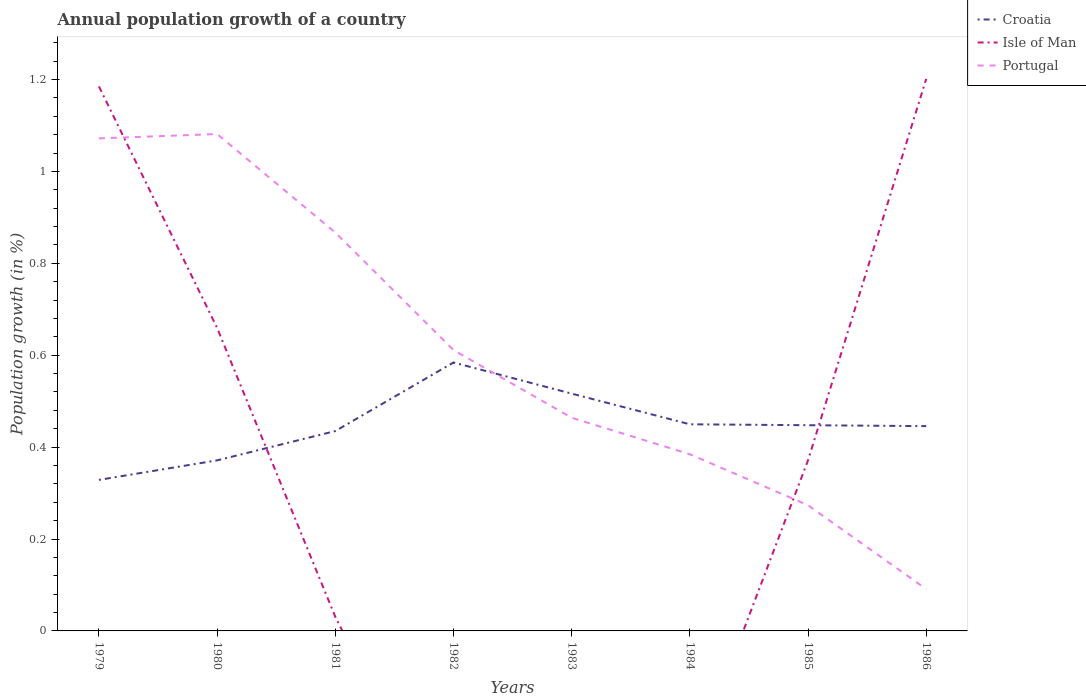How many different coloured lines are there?
Give a very brief answer. 3. Across all years, what is the maximum annual population growth in Isle of Man?
Your response must be concise. 0. What is the total annual population growth in Portugal in the graph?
Keep it short and to the point. 0.47. What is the difference between the highest and the second highest annual population growth in Croatia?
Your response must be concise. 0.26. What is the difference between the highest and the lowest annual population growth in Croatia?
Make the answer very short. 4. Is the annual population growth in Croatia strictly greater than the annual population growth in Portugal over the years?
Ensure brevity in your answer.  No. How many years are there in the graph?
Provide a succinct answer. 8. What is the difference between two consecutive major ticks on the Y-axis?
Your answer should be very brief. 0.2. Are the values on the major ticks of Y-axis written in scientific E-notation?
Ensure brevity in your answer.  No. Does the graph contain grids?
Give a very brief answer. No. How many legend labels are there?
Your answer should be compact. 3. How are the legend labels stacked?
Give a very brief answer. Vertical. What is the title of the graph?
Offer a terse response. Annual population growth of a country. What is the label or title of the X-axis?
Your response must be concise. Years. What is the label or title of the Y-axis?
Offer a very short reply. Population growth (in %). What is the Population growth (in %) in Croatia in 1979?
Make the answer very short. 0.33. What is the Population growth (in %) of Isle of Man in 1979?
Give a very brief answer. 1.19. What is the Population growth (in %) of Portugal in 1979?
Ensure brevity in your answer.  1.07. What is the Population growth (in %) in Croatia in 1980?
Your response must be concise. 0.37. What is the Population growth (in %) of Isle of Man in 1980?
Your answer should be very brief. 0.66. What is the Population growth (in %) in Portugal in 1980?
Make the answer very short. 1.08. What is the Population growth (in %) of Croatia in 1981?
Make the answer very short. 0.43. What is the Population growth (in %) of Isle of Man in 1981?
Make the answer very short. 0.03. What is the Population growth (in %) in Portugal in 1981?
Your answer should be compact. 0.87. What is the Population growth (in %) in Croatia in 1982?
Your answer should be very brief. 0.58. What is the Population growth (in %) in Portugal in 1982?
Offer a terse response. 0.61. What is the Population growth (in %) in Croatia in 1983?
Keep it short and to the point. 0.52. What is the Population growth (in %) in Portugal in 1983?
Your answer should be very brief. 0.46. What is the Population growth (in %) of Croatia in 1984?
Your answer should be very brief. 0.45. What is the Population growth (in %) in Portugal in 1984?
Offer a terse response. 0.38. What is the Population growth (in %) in Croatia in 1985?
Your response must be concise. 0.45. What is the Population growth (in %) in Isle of Man in 1985?
Make the answer very short. 0.37. What is the Population growth (in %) of Portugal in 1985?
Your answer should be compact. 0.27. What is the Population growth (in %) in Croatia in 1986?
Provide a succinct answer. 0.45. What is the Population growth (in %) in Isle of Man in 1986?
Your response must be concise. 1.2. What is the Population growth (in %) of Portugal in 1986?
Give a very brief answer. 0.09. Across all years, what is the maximum Population growth (in %) of Croatia?
Give a very brief answer. 0.58. Across all years, what is the maximum Population growth (in %) in Isle of Man?
Make the answer very short. 1.2. Across all years, what is the maximum Population growth (in %) in Portugal?
Keep it short and to the point. 1.08. Across all years, what is the minimum Population growth (in %) of Croatia?
Ensure brevity in your answer.  0.33. Across all years, what is the minimum Population growth (in %) of Portugal?
Provide a short and direct response. 0.09. What is the total Population growth (in %) in Croatia in the graph?
Your answer should be very brief. 3.58. What is the total Population growth (in %) of Isle of Man in the graph?
Offer a very short reply. 3.45. What is the total Population growth (in %) in Portugal in the graph?
Make the answer very short. 4.84. What is the difference between the Population growth (in %) of Croatia in 1979 and that in 1980?
Offer a very short reply. -0.04. What is the difference between the Population growth (in %) of Isle of Man in 1979 and that in 1980?
Offer a terse response. 0.53. What is the difference between the Population growth (in %) in Portugal in 1979 and that in 1980?
Your answer should be very brief. -0.01. What is the difference between the Population growth (in %) of Croatia in 1979 and that in 1981?
Provide a short and direct response. -0.11. What is the difference between the Population growth (in %) in Isle of Man in 1979 and that in 1981?
Your answer should be very brief. 1.15. What is the difference between the Population growth (in %) in Portugal in 1979 and that in 1981?
Provide a short and direct response. 0.2. What is the difference between the Population growth (in %) in Croatia in 1979 and that in 1982?
Give a very brief answer. -0.26. What is the difference between the Population growth (in %) of Portugal in 1979 and that in 1982?
Provide a succinct answer. 0.46. What is the difference between the Population growth (in %) in Croatia in 1979 and that in 1983?
Your answer should be very brief. -0.19. What is the difference between the Population growth (in %) in Portugal in 1979 and that in 1983?
Offer a very short reply. 0.61. What is the difference between the Population growth (in %) of Croatia in 1979 and that in 1984?
Provide a short and direct response. -0.12. What is the difference between the Population growth (in %) in Portugal in 1979 and that in 1984?
Offer a very short reply. 0.69. What is the difference between the Population growth (in %) in Croatia in 1979 and that in 1985?
Make the answer very short. -0.12. What is the difference between the Population growth (in %) in Isle of Man in 1979 and that in 1985?
Keep it short and to the point. 0.81. What is the difference between the Population growth (in %) of Portugal in 1979 and that in 1985?
Provide a short and direct response. 0.8. What is the difference between the Population growth (in %) of Croatia in 1979 and that in 1986?
Provide a succinct answer. -0.12. What is the difference between the Population growth (in %) of Isle of Man in 1979 and that in 1986?
Offer a very short reply. -0.02. What is the difference between the Population growth (in %) in Croatia in 1980 and that in 1981?
Keep it short and to the point. -0.06. What is the difference between the Population growth (in %) of Isle of Man in 1980 and that in 1981?
Offer a very short reply. 0.63. What is the difference between the Population growth (in %) in Portugal in 1980 and that in 1981?
Your response must be concise. 0.21. What is the difference between the Population growth (in %) in Croatia in 1980 and that in 1982?
Offer a very short reply. -0.21. What is the difference between the Population growth (in %) of Portugal in 1980 and that in 1982?
Offer a terse response. 0.47. What is the difference between the Population growth (in %) of Croatia in 1980 and that in 1983?
Ensure brevity in your answer.  -0.15. What is the difference between the Population growth (in %) in Portugal in 1980 and that in 1983?
Your response must be concise. 0.62. What is the difference between the Population growth (in %) of Croatia in 1980 and that in 1984?
Your answer should be very brief. -0.08. What is the difference between the Population growth (in %) of Portugal in 1980 and that in 1984?
Provide a short and direct response. 0.7. What is the difference between the Population growth (in %) in Croatia in 1980 and that in 1985?
Give a very brief answer. -0.08. What is the difference between the Population growth (in %) in Isle of Man in 1980 and that in 1985?
Make the answer very short. 0.29. What is the difference between the Population growth (in %) in Portugal in 1980 and that in 1985?
Keep it short and to the point. 0.81. What is the difference between the Population growth (in %) in Croatia in 1980 and that in 1986?
Provide a short and direct response. -0.07. What is the difference between the Population growth (in %) of Isle of Man in 1980 and that in 1986?
Offer a terse response. -0.54. What is the difference between the Population growth (in %) of Croatia in 1981 and that in 1982?
Make the answer very short. -0.15. What is the difference between the Population growth (in %) in Portugal in 1981 and that in 1982?
Your answer should be compact. 0.26. What is the difference between the Population growth (in %) of Croatia in 1981 and that in 1983?
Ensure brevity in your answer.  -0.08. What is the difference between the Population growth (in %) of Portugal in 1981 and that in 1983?
Provide a succinct answer. 0.4. What is the difference between the Population growth (in %) of Croatia in 1981 and that in 1984?
Offer a very short reply. -0.01. What is the difference between the Population growth (in %) of Portugal in 1981 and that in 1984?
Give a very brief answer. 0.48. What is the difference between the Population growth (in %) in Croatia in 1981 and that in 1985?
Give a very brief answer. -0.01. What is the difference between the Population growth (in %) of Isle of Man in 1981 and that in 1985?
Your answer should be very brief. -0.34. What is the difference between the Population growth (in %) in Portugal in 1981 and that in 1985?
Your response must be concise. 0.59. What is the difference between the Population growth (in %) of Croatia in 1981 and that in 1986?
Keep it short and to the point. -0.01. What is the difference between the Population growth (in %) in Isle of Man in 1981 and that in 1986?
Give a very brief answer. -1.17. What is the difference between the Population growth (in %) of Portugal in 1981 and that in 1986?
Provide a succinct answer. 0.78. What is the difference between the Population growth (in %) of Croatia in 1982 and that in 1983?
Keep it short and to the point. 0.07. What is the difference between the Population growth (in %) of Portugal in 1982 and that in 1983?
Your answer should be very brief. 0.15. What is the difference between the Population growth (in %) of Croatia in 1982 and that in 1984?
Your response must be concise. 0.13. What is the difference between the Population growth (in %) of Portugal in 1982 and that in 1984?
Your answer should be compact. 0.23. What is the difference between the Population growth (in %) in Croatia in 1982 and that in 1985?
Provide a short and direct response. 0.14. What is the difference between the Population growth (in %) in Portugal in 1982 and that in 1985?
Make the answer very short. 0.34. What is the difference between the Population growth (in %) of Croatia in 1982 and that in 1986?
Offer a very short reply. 0.14. What is the difference between the Population growth (in %) of Portugal in 1982 and that in 1986?
Give a very brief answer. 0.52. What is the difference between the Population growth (in %) of Croatia in 1983 and that in 1984?
Provide a succinct answer. 0.07. What is the difference between the Population growth (in %) of Portugal in 1983 and that in 1984?
Provide a succinct answer. 0.08. What is the difference between the Population growth (in %) in Croatia in 1983 and that in 1985?
Your response must be concise. 0.07. What is the difference between the Population growth (in %) of Portugal in 1983 and that in 1985?
Offer a terse response. 0.19. What is the difference between the Population growth (in %) in Croatia in 1983 and that in 1986?
Keep it short and to the point. 0.07. What is the difference between the Population growth (in %) of Portugal in 1983 and that in 1986?
Provide a short and direct response. 0.37. What is the difference between the Population growth (in %) of Croatia in 1984 and that in 1985?
Provide a succinct answer. 0. What is the difference between the Population growth (in %) of Portugal in 1984 and that in 1985?
Offer a very short reply. 0.11. What is the difference between the Population growth (in %) in Croatia in 1984 and that in 1986?
Your answer should be very brief. 0. What is the difference between the Population growth (in %) of Portugal in 1984 and that in 1986?
Your answer should be very brief. 0.29. What is the difference between the Population growth (in %) in Croatia in 1985 and that in 1986?
Keep it short and to the point. 0. What is the difference between the Population growth (in %) of Isle of Man in 1985 and that in 1986?
Your response must be concise. -0.83. What is the difference between the Population growth (in %) in Portugal in 1985 and that in 1986?
Provide a succinct answer. 0.18. What is the difference between the Population growth (in %) of Croatia in 1979 and the Population growth (in %) of Isle of Man in 1980?
Your answer should be very brief. -0.33. What is the difference between the Population growth (in %) of Croatia in 1979 and the Population growth (in %) of Portugal in 1980?
Your answer should be very brief. -0.75. What is the difference between the Population growth (in %) in Isle of Man in 1979 and the Population growth (in %) in Portugal in 1980?
Ensure brevity in your answer.  0.1. What is the difference between the Population growth (in %) of Croatia in 1979 and the Population growth (in %) of Isle of Man in 1981?
Offer a terse response. 0.3. What is the difference between the Population growth (in %) in Croatia in 1979 and the Population growth (in %) in Portugal in 1981?
Your response must be concise. -0.54. What is the difference between the Population growth (in %) in Isle of Man in 1979 and the Population growth (in %) in Portugal in 1981?
Your response must be concise. 0.32. What is the difference between the Population growth (in %) in Croatia in 1979 and the Population growth (in %) in Portugal in 1982?
Provide a succinct answer. -0.28. What is the difference between the Population growth (in %) of Isle of Man in 1979 and the Population growth (in %) of Portugal in 1982?
Your response must be concise. 0.57. What is the difference between the Population growth (in %) of Croatia in 1979 and the Population growth (in %) of Portugal in 1983?
Give a very brief answer. -0.14. What is the difference between the Population growth (in %) of Isle of Man in 1979 and the Population growth (in %) of Portugal in 1983?
Offer a terse response. 0.72. What is the difference between the Population growth (in %) of Croatia in 1979 and the Population growth (in %) of Portugal in 1984?
Offer a terse response. -0.06. What is the difference between the Population growth (in %) of Isle of Man in 1979 and the Population growth (in %) of Portugal in 1984?
Your answer should be very brief. 0.8. What is the difference between the Population growth (in %) in Croatia in 1979 and the Population growth (in %) in Isle of Man in 1985?
Your answer should be compact. -0.04. What is the difference between the Population growth (in %) in Croatia in 1979 and the Population growth (in %) in Portugal in 1985?
Provide a short and direct response. 0.06. What is the difference between the Population growth (in %) in Isle of Man in 1979 and the Population growth (in %) in Portugal in 1985?
Your answer should be compact. 0.91. What is the difference between the Population growth (in %) in Croatia in 1979 and the Population growth (in %) in Isle of Man in 1986?
Keep it short and to the point. -0.87. What is the difference between the Population growth (in %) in Croatia in 1979 and the Population growth (in %) in Portugal in 1986?
Offer a terse response. 0.24. What is the difference between the Population growth (in %) in Isle of Man in 1979 and the Population growth (in %) in Portugal in 1986?
Ensure brevity in your answer.  1.09. What is the difference between the Population growth (in %) in Croatia in 1980 and the Population growth (in %) in Isle of Man in 1981?
Provide a succinct answer. 0.34. What is the difference between the Population growth (in %) in Croatia in 1980 and the Population growth (in %) in Portugal in 1981?
Your answer should be compact. -0.5. What is the difference between the Population growth (in %) of Isle of Man in 1980 and the Population growth (in %) of Portugal in 1981?
Give a very brief answer. -0.21. What is the difference between the Population growth (in %) in Croatia in 1980 and the Population growth (in %) in Portugal in 1982?
Offer a terse response. -0.24. What is the difference between the Population growth (in %) of Isle of Man in 1980 and the Population growth (in %) of Portugal in 1982?
Your answer should be compact. 0.05. What is the difference between the Population growth (in %) in Croatia in 1980 and the Population growth (in %) in Portugal in 1983?
Your answer should be very brief. -0.09. What is the difference between the Population growth (in %) of Isle of Man in 1980 and the Population growth (in %) of Portugal in 1983?
Your response must be concise. 0.2. What is the difference between the Population growth (in %) in Croatia in 1980 and the Population growth (in %) in Portugal in 1984?
Provide a succinct answer. -0.01. What is the difference between the Population growth (in %) of Isle of Man in 1980 and the Population growth (in %) of Portugal in 1984?
Your answer should be very brief. 0.28. What is the difference between the Population growth (in %) in Croatia in 1980 and the Population growth (in %) in Isle of Man in 1985?
Ensure brevity in your answer.  -0. What is the difference between the Population growth (in %) in Croatia in 1980 and the Population growth (in %) in Portugal in 1985?
Offer a very short reply. 0.1. What is the difference between the Population growth (in %) in Isle of Man in 1980 and the Population growth (in %) in Portugal in 1985?
Your response must be concise. 0.39. What is the difference between the Population growth (in %) in Croatia in 1980 and the Population growth (in %) in Isle of Man in 1986?
Give a very brief answer. -0.83. What is the difference between the Population growth (in %) of Croatia in 1980 and the Population growth (in %) of Portugal in 1986?
Ensure brevity in your answer.  0.28. What is the difference between the Population growth (in %) in Isle of Man in 1980 and the Population growth (in %) in Portugal in 1986?
Make the answer very short. 0.57. What is the difference between the Population growth (in %) in Croatia in 1981 and the Population growth (in %) in Portugal in 1982?
Keep it short and to the point. -0.18. What is the difference between the Population growth (in %) in Isle of Man in 1981 and the Population growth (in %) in Portugal in 1982?
Give a very brief answer. -0.58. What is the difference between the Population growth (in %) in Croatia in 1981 and the Population growth (in %) in Portugal in 1983?
Offer a terse response. -0.03. What is the difference between the Population growth (in %) in Isle of Man in 1981 and the Population growth (in %) in Portugal in 1983?
Offer a terse response. -0.43. What is the difference between the Population growth (in %) of Croatia in 1981 and the Population growth (in %) of Portugal in 1984?
Make the answer very short. 0.05. What is the difference between the Population growth (in %) of Isle of Man in 1981 and the Population growth (in %) of Portugal in 1984?
Make the answer very short. -0.35. What is the difference between the Population growth (in %) of Croatia in 1981 and the Population growth (in %) of Isle of Man in 1985?
Your answer should be compact. 0.06. What is the difference between the Population growth (in %) in Croatia in 1981 and the Population growth (in %) in Portugal in 1985?
Provide a succinct answer. 0.16. What is the difference between the Population growth (in %) of Isle of Man in 1981 and the Population growth (in %) of Portugal in 1985?
Provide a succinct answer. -0.24. What is the difference between the Population growth (in %) of Croatia in 1981 and the Population growth (in %) of Isle of Man in 1986?
Offer a very short reply. -0.77. What is the difference between the Population growth (in %) of Croatia in 1981 and the Population growth (in %) of Portugal in 1986?
Make the answer very short. 0.34. What is the difference between the Population growth (in %) of Isle of Man in 1981 and the Population growth (in %) of Portugal in 1986?
Your response must be concise. -0.06. What is the difference between the Population growth (in %) in Croatia in 1982 and the Population growth (in %) in Portugal in 1983?
Your answer should be compact. 0.12. What is the difference between the Population growth (in %) in Croatia in 1982 and the Population growth (in %) in Portugal in 1984?
Give a very brief answer. 0.2. What is the difference between the Population growth (in %) in Croatia in 1982 and the Population growth (in %) in Isle of Man in 1985?
Make the answer very short. 0.21. What is the difference between the Population growth (in %) of Croatia in 1982 and the Population growth (in %) of Portugal in 1985?
Your answer should be compact. 0.31. What is the difference between the Population growth (in %) in Croatia in 1982 and the Population growth (in %) in Isle of Man in 1986?
Make the answer very short. -0.62. What is the difference between the Population growth (in %) of Croatia in 1982 and the Population growth (in %) of Portugal in 1986?
Provide a succinct answer. 0.49. What is the difference between the Population growth (in %) in Croatia in 1983 and the Population growth (in %) in Portugal in 1984?
Offer a very short reply. 0.13. What is the difference between the Population growth (in %) in Croatia in 1983 and the Population growth (in %) in Isle of Man in 1985?
Make the answer very short. 0.14. What is the difference between the Population growth (in %) of Croatia in 1983 and the Population growth (in %) of Portugal in 1985?
Offer a terse response. 0.24. What is the difference between the Population growth (in %) of Croatia in 1983 and the Population growth (in %) of Isle of Man in 1986?
Provide a succinct answer. -0.69. What is the difference between the Population growth (in %) in Croatia in 1983 and the Population growth (in %) in Portugal in 1986?
Give a very brief answer. 0.43. What is the difference between the Population growth (in %) of Croatia in 1984 and the Population growth (in %) of Isle of Man in 1985?
Provide a succinct answer. 0.08. What is the difference between the Population growth (in %) of Croatia in 1984 and the Population growth (in %) of Portugal in 1985?
Offer a very short reply. 0.18. What is the difference between the Population growth (in %) in Croatia in 1984 and the Population growth (in %) in Isle of Man in 1986?
Ensure brevity in your answer.  -0.75. What is the difference between the Population growth (in %) in Croatia in 1984 and the Population growth (in %) in Portugal in 1986?
Make the answer very short. 0.36. What is the difference between the Population growth (in %) in Croatia in 1985 and the Population growth (in %) in Isle of Man in 1986?
Provide a short and direct response. -0.75. What is the difference between the Population growth (in %) in Croatia in 1985 and the Population growth (in %) in Portugal in 1986?
Ensure brevity in your answer.  0.36. What is the difference between the Population growth (in %) in Isle of Man in 1985 and the Population growth (in %) in Portugal in 1986?
Provide a succinct answer. 0.28. What is the average Population growth (in %) in Croatia per year?
Provide a short and direct response. 0.45. What is the average Population growth (in %) of Isle of Man per year?
Your answer should be compact. 0.43. What is the average Population growth (in %) in Portugal per year?
Give a very brief answer. 0.61. In the year 1979, what is the difference between the Population growth (in %) in Croatia and Population growth (in %) in Isle of Man?
Keep it short and to the point. -0.86. In the year 1979, what is the difference between the Population growth (in %) of Croatia and Population growth (in %) of Portugal?
Keep it short and to the point. -0.74. In the year 1979, what is the difference between the Population growth (in %) in Isle of Man and Population growth (in %) in Portugal?
Ensure brevity in your answer.  0.11. In the year 1980, what is the difference between the Population growth (in %) of Croatia and Population growth (in %) of Isle of Man?
Your answer should be very brief. -0.29. In the year 1980, what is the difference between the Population growth (in %) in Croatia and Population growth (in %) in Portugal?
Offer a terse response. -0.71. In the year 1980, what is the difference between the Population growth (in %) of Isle of Man and Population growth (in %) of Portugal?
Provide a succinct answer. -0.42. In the year 1981, what is the difference between the Population growth (in %) in Croatia and Population growth (in %) in Isle of Man?
Offer a terse response. 0.4. In the year 1981, what is the difference between the Population growth (in %) of Croatia and Population growth (in %) of Portugal?
Keep it short and to the point. -0.43. In the year 1981, what is the difference between the Population growth (in %) of Isle of Man and Population growth (in %) of Portugal?
Provide a short and direct response. -0.84. In the year 1982, what is the difference between the Population growth (in %) of Croatia and Population growth (in %) of Portugal?
Your answer should be very brief. -0.03. In the year 1983, what is the difference between the Population growth (in %) of Croatia and Population growth (in %) of Portugal?
Ensure brevity in your answer.  0.05. In the year 1984, what is the difference between the Population growth (in %) in Croatia and Population growth (in %) in Portugal?
Keep it short and to the point. 0.07. In the year 1985, what is the difference between the Population growth (in %) of Croatia and Population growth (in %) of Isle of Man?
Keep it short and to the point. 0.08. In the year 1985, what is the difference between the Population growth (in %) in Croatia and Population growth (in %) in Portugal?
Provide a succinct answer. 0.17. In the year 1985, what is the difference between the Population growth (in %) of Isle of Man and Population growth (in %) of Portugal?
Give a very brief answer. 0.1. In the year 1986, what is the difference between the Population growth (in %) of Croatia and Population growth (in %) of Isle of Man?
Provide a short and direct response. -0.76. In the year 1986, what is the difference between the Population growth (in %) of Croatia and Population growth (in %) of Portugal?
Offer a very short reply. 0.35. In the year 1986, what is the difference between the Population growth (in %) of Isle of Man and Population growth (in %) of Portugal?
Your answer should be compact. 1.11. What is the ratio of the Population growth (in %) of Croatia in 1979 to that in 1980?
Your answer should be very brief. 0.89. What is the ratio of the Population growth (in %) of Isle of Man in 1979 to that in 1980?
Make the answer very short. 1.8. What is the ratio of the Population growth (in %) of Portugal in 1979 to that in 1980?
Offer a very short reply. 0.99. What is the ratio of the Population growth (in %) of Croatia in 1979 to that in 1981?
Your answer should be compact. 0.76. What is the ratio of the Population growth (in %) in Isle of Man in 1979 to that in 1981?
Your response must be concise. 38.59. What is the ratio of the Population growth (in %) in Portugal in 1979 to that in 1981?
Provide a succinct answer. 1.24. What is the ratio of the Population growth (in %) in Croatia in 1979 to that in 1982?
Offer a very short reply. 0.56. What is the ratio of the Population growth (in %) in Portugal in 1979 to that in 1982?
Offer a very short reply. 1.75. What is the ratio of the Population growth (in %) in Croatia in 1979 to that in 1983?
Your response must be concise. 0.64. What is the ratio of the Population growth (in %) in Portugal in 1979 to that in 1983?
Provide a succinct answer. 2.31. What is the ratio of the Population growth (in %) in Croatia in 1979 to that in 1984?
Provide a succinct answer. 0.73. What is the ratio of the Population growth (in %) in Portugal in 1979 to that in 1984?
Your answer should be very brief. 2.79. What is the ratio of the Population growth (in %) in Croatia in 1979 to that in 1985?
Provide a short and direct response. 0.73. What is the ratio of the Population growth (in %) of Isle of Man in 1979 to that in 1985?
Your answer should be compact. 3.19. What is the ratio of the Population growth (in %) in Portugal in 1979 to that in 1985?
Ensure brevity in your answer.  3.92. What is the ratio of the Population growth (in %) of Croatia in 1979 to that in 1986?
Make the answer very short. 0.74. What is the ratio of the Population growth (in %) of Isle of Man in 1979 to that in 1986?
Provide a succinct answer. 0.99. What is the ratio of the Population growth (in %) in Portugal in 1979 to that in 1986?
Your response must be concise. 11.79. What is the ratio of the Population growth (in %) in Croatia in 1980 to that in 1981?
Provide a succinct answer. 0.85. What is the ratio of the Population growth (in %) in Isle of Man in 1980 to that in 1981?
Ensure brevity in your answer.  21.47. What is the ratio of the Population growth (in %) in Portugal in 1980 to that in 1981?
Make the answer very short. 1.25. What is the ratio of the Population growth (in %) in Croatia in 1980 to that in 1982?
Give a very brief answer. 0.64. What is the ratio of the Population growth (in %) in Portugal in 1980 to that in 1982?
Provide a short and direct response. 1.77. What is the ratio of the Population growth (in %) of Croatia in 1980 to that in 1983?
Your response must be concise. 0.72. What is the ratio of the Population growth (in %) of Portugal in 1980 to that in 1983?
Make the answer very short. 2.33. What is the ratio of the Population growth (in %) in Croatia in 1980 to that in 1984?
Offer a terse response. 0.83. What is the ratio of the Population growth (in %) in Portugal in 1980 to that in 1984?
Provide a short and direct response. 2.81. What is the ratio of the Population growth (in %) in Croatia in 1980 to that in 1985?
Give a very brief answer. 0.83. What is the ratio of the Population growth (in %) of Isle of Man in 1980 to that in 1985?
Make the answer very short. 1.78. What is the ratio of the Population growth (in %) in Portugal in 1980 to that in 1985?
Your answer should be very brief. 3.95. What is the ratio of the Population growth (in %) in Croatia in 1980 to that in 1986?
Your response must be concise. 0.83. What is the ratio of the Population growth (in %) in Isle of Man in 1980 to that in 1986?
Give a very brief answer. 0.55. What is the ratio of the Population growth (in %) in Portugal in 1980 to that in 1986?
Offer a very short reply. 11.89. What is the ratio of the Population growth (in %) of Croatia in 1981 to that in 1982?
Your answer should be very brief. 0.74. What is the ratio of the Population growth (in %) in Portugal in 1981 to that in 1982?
Ensure brevity in your answer.  1.42. What is the ratio of the Population growth (in %) in Croatia in 1981 to that in 1983?
Give a very brief answer. 0.84. What is the ratio of the Population growth (in %) of Portugal in 1981 to that in 1983?
Offer a very short reply. 1.87. What is the ratio of the Population growth (in %) in Croatia in 1981 to that in 1984?
Ensure brevity in your answer.  0.97. What is the ratio of the Population growth (in %) of Portugal in 1981 to that in 1984?
Offer a terse response. 2.25. What is the ratio of the Population growth (in %) of Croatia in 1981 to that in 1985?
Your answer should be very brief. 0.97. What is the ratio of the Population growth (in %) in Isle of Man in 1981 to that in 1985?
Your response must be concise. 0.08. What is the ratio of the Population growth (in %) of Portugal in 1981 to that in 1985?
Your response must be concise. 3.17. What is the ratio of the Population growth (in %) of Croatia in 1981 to that in 1986?
Offer a very short reply. 0.98. What is the ratio of the Population growth (in %) of Isle of Man in 1981 to that in 1986?
Your answer should be very brief. 0.03. What is the ratio of the Population growth (in %) in Portugal in 1981 to that in 1986?
Your answer should be compact. 9.53. What is the ratio of the Population growth (in %) of Croatia in 1982 to that in 1983?
Offer a very short reply. 1.13. What is the ratio of the Population growth (in %) of Portugal in 1982 to that in 1983?
Your answer should be compact. 1.32. What is the ratio of the Population growth (in %) in Croatia in 1982 to that in 1984?
Make the answer very short. 1.3. What is the ratio of the Population growth (in %) of Portugal in 1982 to that in 1984?
Your answer should be compact. 1.59. What is the ratio of the Population growth (in %) of Croatia in 1982 to that in 1985?
Your answer should be very brief. 1.3. What is the ratio of the Population growth (in %) of Portugal in 1982 to that in 1985?
Offer a terse response. 2.23. What is the ratio of the Population growth (in %) in Croatia in 1982 to that in 1986?
Offer a very short reply. 1.31. What is the ratio of the Population growth (in %) in Portugal in 1982 to that in 1986?
Your answer should be very brief. 6.72. What is the ratio of the Population growth (in %) of Croatia in 1983 to that in 1984?
Ensure brevity in your answer.  1.15. What is the ratio of the Population growth (in %) of Portugal in 1983 to that in 1984?
Ensure brevity in your answer.  1.21. What is the ratio of the Population growth (in %) in Croatia in 1983 to that in 1985?
Make the answer very short. 1.15. What is the ratio of the Population growth (in %) in Portugal in 1983 to that in 1985?
Offer a very short reply. 1.7. What is the ratio of the Population growth (in %) in Croatia in 1983 to that in 1986?
Ensure brevity in your answer.  1.16. What is the ratio of the Population growth (in %) of Portugal in 1983 to that in 1986?
Your answer should be very brief. 5.1. What is the ratio of the Population growth (in %) in Portugal in 1984 to that in 1985?
Provide a succinct answer. 1.41. What is the ratio of the Population growth (in %) of Portugal in 1984 to that in 1986?
Provide a short and direct response. 4.23. What is the ratio of the Population growth (in %) in Croatia in 1985 to that in 1986?
Give a very brief answer. 1. What is the ratio of the Population growth (in %) in Isle of Man in 1985 to that in 1986?
Provide a succinct answer. 0.31. What is the ratio of the Population growth (in %) of Portugal in 1985 to that in 1986?
Keep it short and to the point. 3.01. What is the difference between the highest and the second highest Population growth (in %) of Croatia?
Your answer should be compact. 0.07. What is the difference between the highest and the second highest Population growth (in %) of Isle of Man?
Give a very brief answer. 0.02. What is the difference between the highest and the second highest Population growth (in %) in Portugal?
Your response must be concise. 0.01. What is the difference between the highest and the lowest Population growth (in %) in Croatia?
Provide a succinct answer. 0.26. What is the difference between the highest and the lowest Population growth (in %) in Isle of Man?
Keep it short and to the point. 1.2. 